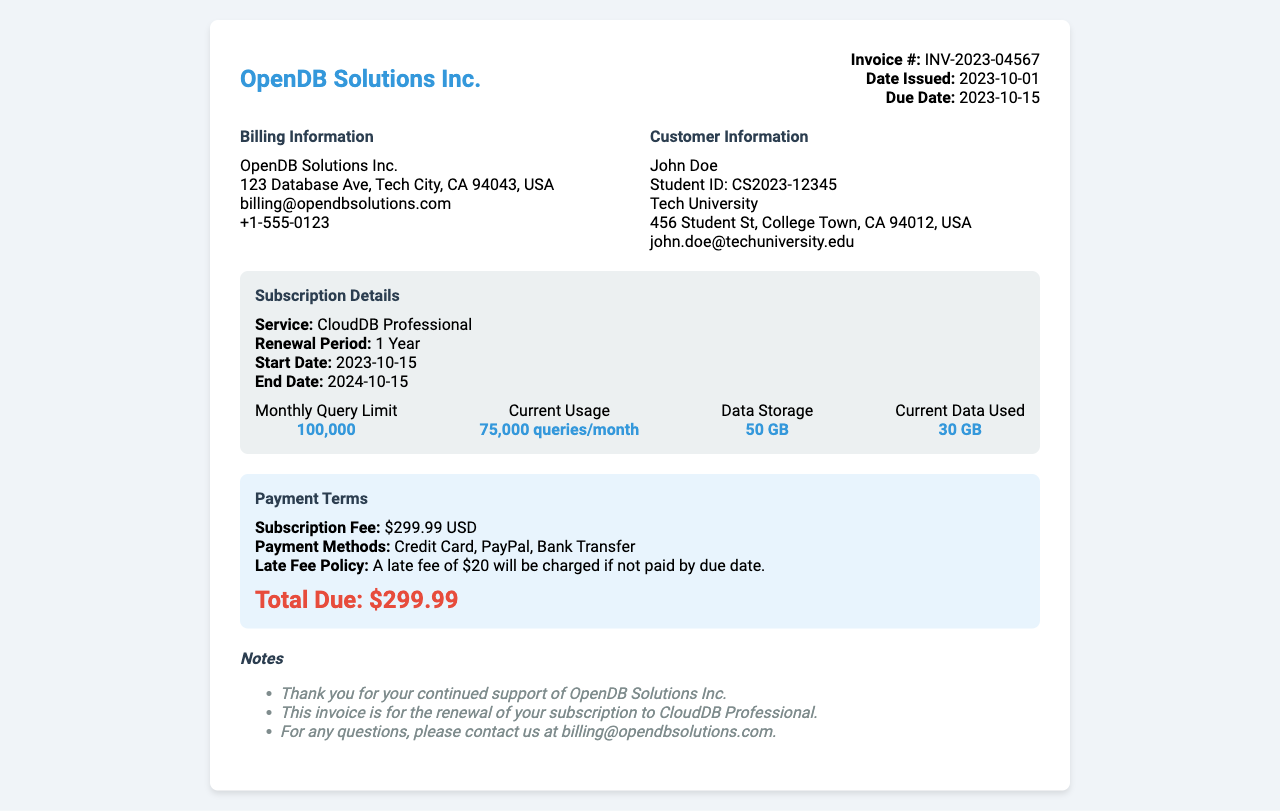What is the invoice number? The invoice number is specified in the document as part of the invoice details section.
Answer: INV-2023-04567 What is the due date? The due date is explicitly stated under the invoice details section.
Answer: 2023-10-15 Who is the customer? The customer's name is listed in the customer information section.
Answer: John Doe What is the subscription fee? The subscription fee is mentioned in the payment terms section near the total due amount.
Answer: $299.99 USD What is the current data used? The current data used is provided in the usage stats of the subscription details section.
Answer: 30 GB What are the payment methods available? The payment methods are described under the payment terms section of the invoice.
Answer: Credit Card, PayPal, Bank Transfer What is the monthly query limit? The monthly query limit is indicated in the usage stats area of the document.
Answer: 100,000 What will happen if the payment is late? The late fee policy is mentioned in the payment terms section explaining consequences for late payments.
Answer: $20 late fee How long is the renewal period? The renewal period is specified in the subscription details section of the invoice.
Answer: 1 Year 